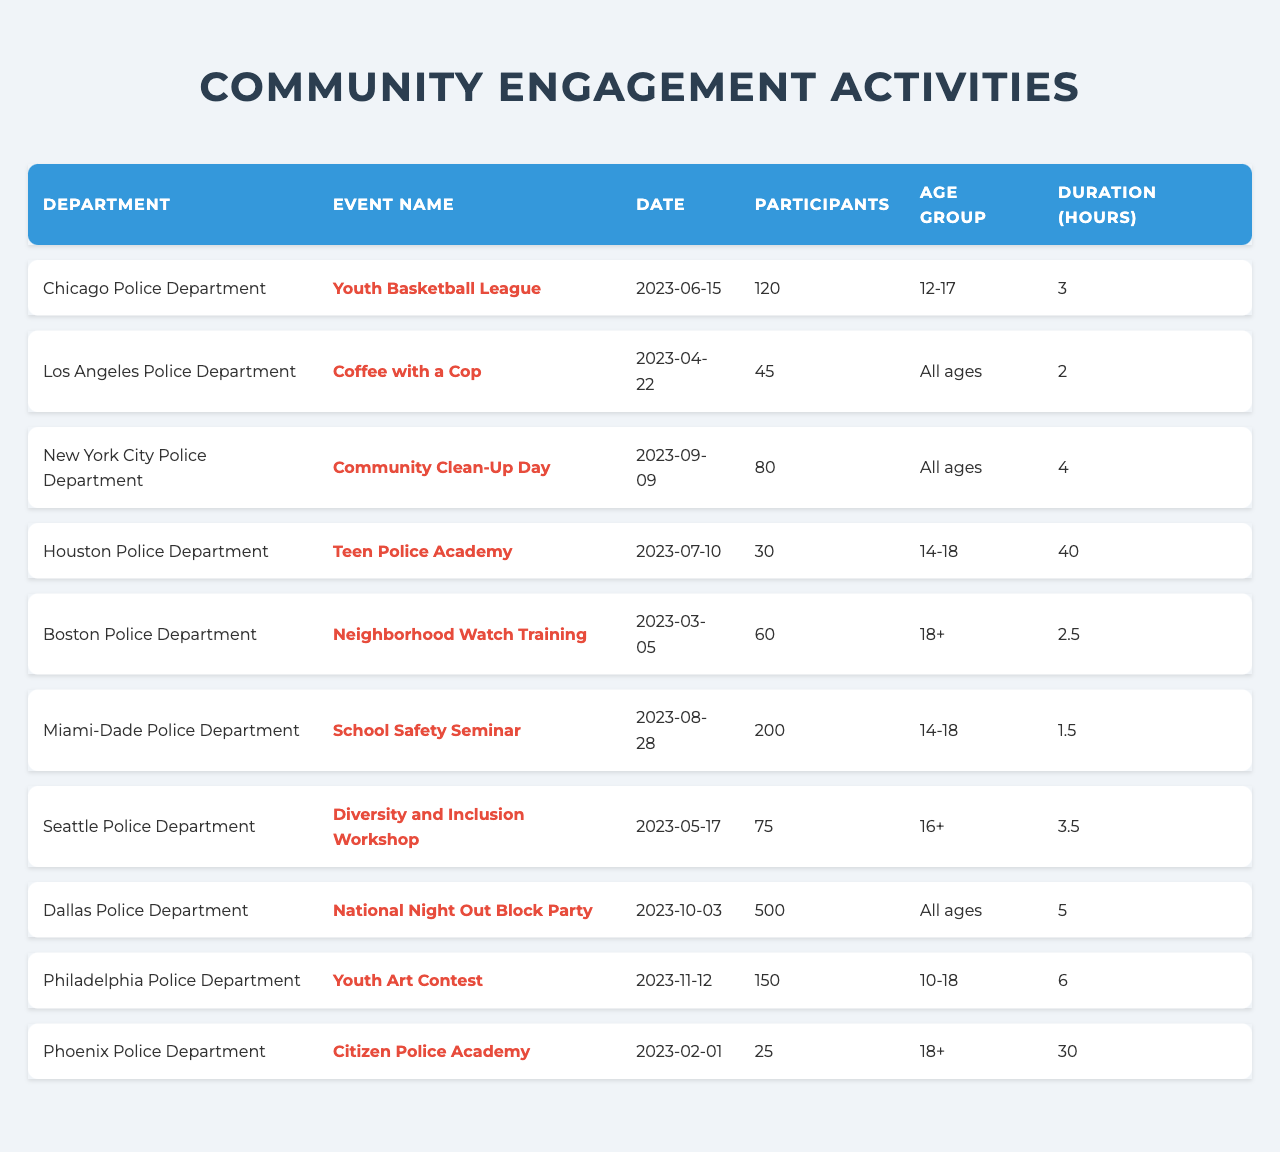What was the most recent community engagement activity held? The most recent activity can be found by checking the "Date" column and identifying the latest date. The latest date is "2023-11-12" for the "Youth Art Contest" organized by the Philadelphia Police Department.
Answer: Youth Art Contest Which police department had the highest number of participants? By looking through the "Participants" column, the largest number is 500, which is the "National Night Out Block Party" organized by the Dallas Police Department.
Answer: Dallas Police Department How many total participants attended activities focused on ages 14-18? The age groups focused on 14-18 are the "Teen Police Academy" (30 participants) and the "School Safety Seminar" (200 participants). Summing these gives us 30 + 200 = 230 total participants.
Answer: 230 Is there an event that had participants across all age groups? To determine this, we look for events in the "Age Group" column marked as "All ages". Both "Coffee with a Cop" and "National Night Out Block Party" are listed as such.
Answer: Yes What is the total duration of all activities held? We will sum the "Duration (hours)" for each event. The total is 3 + 2 + 4 + 40 + 2.5 + 1.5 + 3.5 + 5 + 6 + 30 = 93.5 hours.
Answer: 93.5 hours Which event attracted the youngest participants? The table shows that the event with the lowest age group mentioned is the "Youth Basketball League" for ages 12-17, making it the event with the youngest participants.
Answer: Youth Basketball League What percentage of participants were from the Miami-Dade Police Department? In total, there are 500 participants from the Dallas Police Department, as noted earlier. The Miami-Dade Police Department had 200 participants in the "School Safety Seminar". To find the percentage: (200 / 500) * 100 = 40%.
Answer: 40% Which police department organized an activity focused on diversity? The "Diversity and Inclusion Workshop" is associated with the Seattle Police Department, which indicates their focus on diversity.
Answer: Seattle Police Department What was the average number of participants across all activities? We will add the total participants: 120 + 45 + 80 + 30 + 60 + 200 + 75 + 500 + 150 + 25 = 1,315. Since there are 10 activities, we divide 1,315 by 10 to get the average which is 131.5.
Answer: 131.5 Did any event last longer than 5 hours? By reviewing the "Duration (hours)" column, only the "Teen Police Academy" had a duration of 40 hours, which exceeds 5 hours.
Answer: Yes 